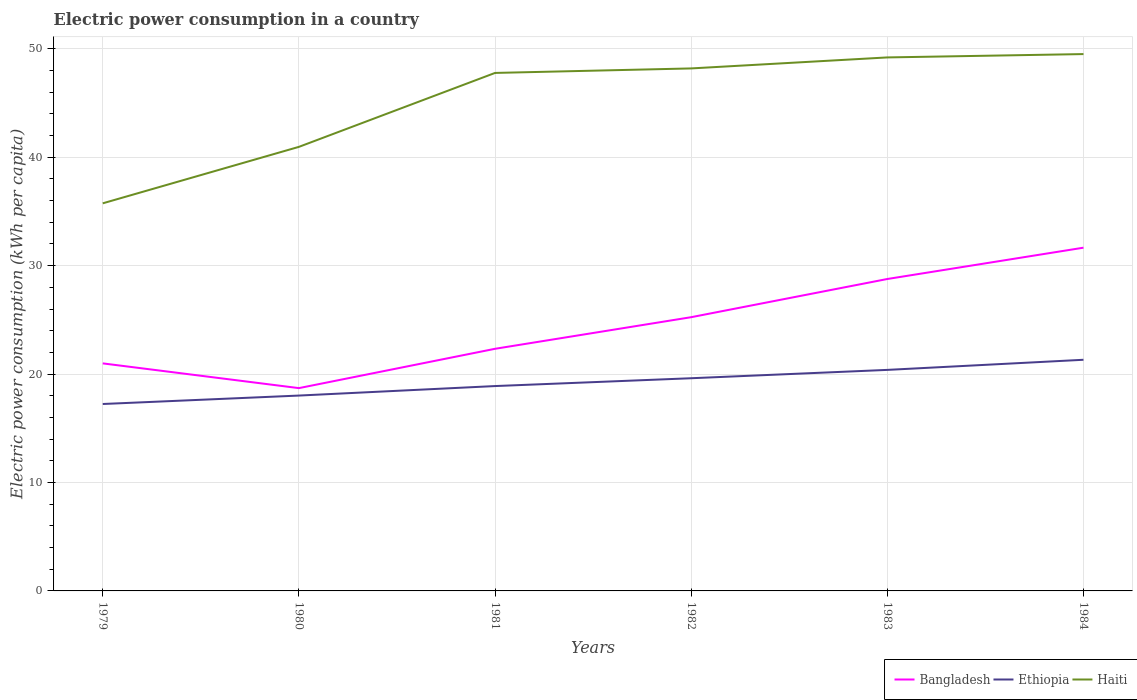How many different coloured lines are there?
Offer a terse response. 3. Across all years, what is the maximum electric power consumption in in Bangladesh?
Your response must be concise. 18.71. In which year was the electric power consumption in in Ethiopia maximum?
Your answer should be very brief. 1979. What is the total electric power consumption in in Bangladesh in the graph?
Give a very brief answer. -3.52. What is the difference between the highest and the second highest electric power consumption in in Haiti?
Your response must be concise. 13.77. What is the difference between the highest and the lowest electric power consumption in in Bangladesh?
Your answer should be compact. 3. Is the electric power consumption in in Haiti strictly greater than the electric power consumption in in Bangladesh over the years?
Your answer should be compact. No. How many lines are there?
Offer a terse response. 3. Are the values on the major ticks of Y-axis written in scientific E-notation?
Keep it short and to the point. No. Does the graph contain any zero values?
Your answer should be compact. No. How many legend labels are there?
Offer a terse response. 3. How are the legend labels stacked?
Keep it short and to the point. Horizontal. What is the title of the graph?
Provide a short and direct response. Electric power consumption in a country. Does "Cambodia" appear as one of the legend labels in the graph?
Make the answer very short. No. What is the label or title of the X-axis?
Keep it short and to the point. Years. What is the label or title of the Y-axis?
Offer a very short reply. Electric power consumption (kWh per capita). What is the Electric power consumption (kWh per capita) in Bangladesh in 1979?
Provide a succinct answer. 20.99. What is the Electric power consumption (kWh per capita) in Ethiopia in 1979?
Keep it short and to the point. 17.24. What is the Electric power consumption (kWh per capita) of Haiti in 1979?
Keep it short and to the point. 35.75. What is the Electric power consumption (kWh per capita) in Bangladesh in 1980?
Offer a terse response. 18.71. What is the Electric power consumption (kWh per capita) in Ethiopia in 1980?
Offer a terse response. 18.02. What is the Electric power consumption (kWh per capita) in Haiti in 1980?
Give a very brief answer. 40.96. What is the Electric power consumption (kWh per capita) in Bangladesh in 1981?
Your answer should be compact. 22.33. What is the Electric power consumption (kWh per capita) of Ethiopia in 1981?
Your response must be concise. 18.9. What is the Electric power consumption (kWh per capita) of Haiti in 1981?
Provide a succinct answer. 47.78. What is the Electric power consumption (kWh per capita) of Bangladesh in 1982?
Provide a succinct answer. 25.25. What is the Electric power consumption (kWh per capita) in Ethiopia in 1982?
Your answer should be very brief. 19.62. What is the Electric power consumption (kWh per capita) of Haiti in 1982?
Provide a short and direct response. 48.19. What is the Electric power consumption (kWh per capita) in Bangladesh in 1983?
Your answer should be very brief. 28.77. What is the Electric power consumption (kWh per capita) in Ethiopia in 1983?
Ensure brevity in your answer.  20.39. What is the Electric power consumption (kWh per capita) in Haiti in 1983?
Provide a succinct answer. 49.21. What is the Electric power consumption (kWh per capita) in Bangladesh in 1984?
Your answer should be compact. 31.66. What is the Electric power consumption (kWh per capita) in Ethiopia in 1984?
Offer a terse response. 21.32. What is the Electric power consumption (kWh per capita) of Haiti in 1984?
Make the answer very short. 49.52. Across all years, what is the maximum Electric power consumption (kWh per capita) of Bangladesh?
Ensure brevity in your answer.  31.66. Across all years, what is the maximum Electric power consumption (kWh per capita) in Ethiopia?
Offer a terse response. 21.32. Across all years, what is the maximum Electric power consumption (kWh per capita) in Haiti?
Keep it short and to the point. 49.52. Across all years, what is the minimum Electric power consumption (kWh per capita) of Bangladesh?
Provide a succinct answer. 18.71. Across all years, what is the minimum Electric power consumption (kWh per capita) of Ethiopia?
Ensure brevity in your answer.  17.24. Across all years, what is the minimum Electric power consumption (kWh per capita) of Haiti?
Give a very brief answer. 35.75. What is the total Electric power consumption (kWh per capita) in Bangladesh in the graph?
Offer a very short reply. 147.7. What is the total Electric power consumption (kWh per capita) in Ethiopia in the graph?
Provide a succinct answer. 115.48. What is the total Electric power consumption (kWh per capita) of Haiti in the graph?
Offer a terse response. 271.4. What is the difference between the Electric power consumption (kWh per capita) of Bangladesh in 1979 and that in 1980?
Offer a terse response. 2.28. What is the difference between the Electric power consumption (kWh per capita) of Ethiopia in 1979 and that in 1980?
Provide a succinct answer. -0.78. What is the difference between the Electric power consumption (kWh per capita) of Haiti in 1979 and that in 1980?
Give a very brief answer. -5.21. What is the difference between the Electric power consumption (kWh per capita) in Bangladesh in 1979 and that in 1981?
Provide a succinct answer. -1.34. What is the difference between the Electric power consumption (kWh per capita) in Ethiopia in 1979 and that in 1981?
Your answer should be very brief. -1.65. What is the difference between the Electric power consumption (kWh per capita) of Haiti in 1979 and that in 1981?
Your answer should be compact. -12.03. What is the difference between the Electric power consumption (kWh per capita) in Bangladesh in 1979 and that in 1982?
Offer a very short reply. -4.26. What is the difference between the Electric power consumption (kWh per capita) of Ethiopia in 1979 and that in 1982?
Provide a succinct answer. -2.38. What is the difference between the Electric power consumption (kWh per capita) of Haiti in 1979 and that in 1982?
Your response must be concise. -12.44. What is the difference between the Electric power consumption (kWh per capita) of Bangladesh in 1979 and that in 1983?
Provide a short and direct response. -7.78. What is the difference between the Electric power consumption (kWh per capita) in Ethiopia in 1979 and that in 1983?
Offer a terse response. -3.15. What is the difference between the Electric power consumption (kWh per capita) in Haiti in 1979 and that in 1983?
Your response must be concise. -13.46. What is the difference between the Electric power consumption (kWh per capita) of Bangladesh in 1979 and that in 1984?
Give a very brief answer. -10.67. What is the difference between the Electric power consumption (kWh per capita) of Ethiopia in 1979 and that in 1984?
Offer a very short reply. -4.08. What is the difference between the Electric power consumption (kWh per capita) in Haiti in 1979 and that in 1984?
Provide a short and direct response. -13.77. What is the difference between the Electric power consumption (kWh per capita) of Bangladesh in 1980 and that in 1981?
Make the answer very short. -3.63. What is the difference between the Electric power consumption (kWh per capita) in Ethiopia in 1980 and that in 1981?
Your answer should be compact. -0.88. What is the difference between the Electric power consumption (kWh per capita) of Haiti in 1980 and that in 1981?
Provide a short and direct response. -6.82. What is the difference between the Electric power consumption (kWh per capita) of Bangladesh in 1980 and that in 1982?
Make the answer very short. -6.54. What is the difference between the Electric power consumption (kWh per capita) in Ethiopia in 1980 and that in 1982?
Provide a succinct answer. -1.6. What is the difference between the Electric power consumption (kWh per capita) in Haiti in 1980 and that in 1982?
Your answer should be compact. -7.24. What is the difference between the Electric power consumption (kWh per capita) of Bangladesh in 1980 and that in 1983?
Offer a very short reply. -10.06. What is the difference between the Electric power consumption (kWh per capita) of Ethiopia in 1980 and that in 1983?
Your response must be concise. -2.37. What is the difference between the Electric power consumption (kWh per capita) in Haiti in 1980 and that in 1983?
Your response must be concise. -8.25. What is the difference between the Electric power consumption (kWh per capita) in Bangladesh in 1980 and that in 1984?
Make the answer very short. -12.95. What is the difference between the Electric power consumption (kWh per capita) in Ethiopia in 1980 and that in 1984?
Offer a terse response. -3.3. What is the difference between the Electric power consumption (kWh per capita) in Haiti in 1980 and that in 1984?
Provide a succinct answer. -8.56. What is the difference between the Electric power consumption (kWh per capita) in Bangladesh in 1981 and that in 1982?
Ensure brevity in your answer.  -2.92. What is the difference between the Electric power consumption (kWh per capita) of Ethiopia in 1981 and that in 1982?
Give a very brief answer. -0.72. What is the difference between the Electric power consumption (kWh per capita) of Haiti in 1981 and that in 1982?
Keep it short and to the point. -0.42. What is the difference between the Electric power consumption (kWh per capita) in Bangladesh in 1981 and that in 1983?
Ensure brevity in your answer.  -6.44. What is the difference between the Electric power consumption (kWh per capita) in Ethiopia in 1981 and that in 1983?
Keep it short and to the point. -1.49. What is the difference between the Electric power consumption (kWh per capita) in Haiti in 1981 and that in 1983?
Your response must be concise. -1.43. What is the difference between the Electric power consumption (kWh per capita) of Bangladesh in 1981 and that in 1984?
Your response must be concise. -9.33. What is the difference between the Electric power consumption (kWh per capita) of Ethiopia in 1981 and that in 1984?
Give a very brief answer. -2.42. What is the difference between the Electric power consumption (kWh per capita) of Haiti in 1981 and that in 1984?
Your response must be concise. -1.74. What is the difference between the Electric power consumption (kWh per capita) of Bangladesh in 1982 and that in 1983?
Your response must be concise. -3.52. What is the difference between the Electric power consumption (kWh per capita) in Ethiopia in 1982 and that in 1983?
Offer a very short reply. -0.77. What is the difference between the Electric power consumption (kWh per capita) of Haiti in 1982 and that in 1983?
Provide a short and direct response. -1.01. What is the difference between the Electric power consumption (kWh per capita) of Bangladesh in 1982 and that in 1984?
Make the answer very short. -6.41. What is the difference between the Electric power consumption (kWh per capita) of Ethiopia in 1982 and that in 1984?
Keep it short and to the point. -1.7. What is the difference between the Electric power consumption (kWh per capita) of Haiti in 1982 and that in 1984?
Offer a terse response. -1.32. What is the difference between the Electric power consumption (kWh per capita) in Bangladesh in 1983 and that in 1984?
Your response must be concise. -2.89. What is the difference between the Electric power consumption (kWh per capita) in Ethiopia in 1983 and that in 1984?
Provide a succinct answer. -0.93. What is the difference between the Electric power consumption (kWh per capita) of Haiti in 1983 and that in 1984?
Give a very brief answer. -0.31. What is the difference between the Electric power consumption (kWh per capita) of Bangladesh in 1979 and the Electric power consumption (kWh per capita) of Ethiopia in 1980?
Offer a terse response. 2.97. What is the difference between the Electric power consumption (kWh per capita) of Bangladesh in 1979 and the Electric power consumption (kWh per capita) of Haiti in 1980?
Give a very brief answer. -19.97. What is the difference between the Electric power consumption (kWh per capita) in Ethiopia in 1979 and the Electric power consumption (kWh per capita) in Haiti in 1980?
Offer a very short reply. -23.72. What is the difference between the Electric power consumption (kWh per capita) of Bangladesh in 1979 and the Electric power consumption (kWh per capita) of Ethiopia in 1981?
Give a very brief answer. 2.09. What is the difference between the Electric power consumption (kWh per capita) of Bangladesh in 1979 and the Electric power consumption (kWh per capita) of Haiti in 1981?
Ensure brevity in your answer.  -26.79. What is the difference between the Electric power consumption (kWh per capita) in Ethiopia in 1979 and the Electric power consumption (kWh per capita) in Haiti in 1981?
Your response must be concise. -30.54. What is the difference between the Electric power consumption (kWh per capita) of Bangladesh in 1979 and the Electric power consumption (kWh per capita) of Ethiopia in 1982?
Keep it short and to the point. 1.37. What is the difference between the Electric power consumption (kWh per capita) in Bangladesh in 1979 and the Electric power consumption (kWh per capita) in Haiti in 1982?
Your answer should be compact. -27.2. What is the difference between the Electric power consumption (kWh per capita) of Ethiopia in 1979 and the Electric power consumption (kWh per capita) of Haiti in 1982?
Make the answer very short. -30.95. What is the difference between the Electric power consumption (kWh per capita) in Bangladesh in 1979 and the Electric power consumption (kWh per capita) in Ethiopia in 1983?
Make the answer very short. 0.6. What is the difference between the Electric power consumption (kWh per capita) of Bangladesh in 1979 and the Electric power consumption (kWh per capita) of Haiti in 1983?
Make the answer very short. -28.22. What is the difference between the Electric power consumption (kWh per capita) in Ethiopia in 1979 and the Electric power consumption (kWh per capita) in Haiti in 1983?
Give a very brief answer. -31.97. What is the difference between the Electric power consumption (kWh per capita) in Bangladesh in 1979 and the Electric power consumption (kWh per capita) in Ethiopia in 1984?
Make the answer very short. -0.33. What is the difference between the Electric power consumption (kWh per capita) in Bangladesh in 1979 and the Electric power consumption (kWh per capita) in Haiti in 1984?
Offer a terse response. -28.53. What is the difference between the Electric power consumption (kWh per capita) in Ethiopia in 1979 and the Electric power consumption (kWh per capita) in Haiti in 1984?
Offer a very short reply. -32.28. What is the difference between the Electric power consumption (kWh per capita) of Bangladesh in 1980 and the Electric power consumption (kWh per capita) of Ethiopia in 1981?
Give a very brief answer. -0.19. What is the difference between the Electric power consumption (kWh per capita) of Bangladesh in 1980 and the Electric power consumption (kWh per capita) of Haiti in 1981?
Give a very brief answer. -29.07. What is the difference between the Electric power consumption (kWh per capita) in Ethiopia in 1980 and the Electric power consumption (kWh per capita) in Haiti in 1981?
Keep it short and to the point. -29.76. What is the difference between the Electric power consumption (kWh per capita) of Bangladesh in 1980 and the Electric power consumption (kWh per capita) of Ethiopia in 1982?
Ensure brevity in your answer.  -0.91. What is the difference between the Electric power consumption (kWh per capita) in Bangladesh in 1980 and the Electric power consumption (kWh per capita) in Haiti in 1982?
Your answer should be very brief. -29.49. What is the difference between the Electric power consumption (kWh per capita) of Ethiopia in 1980 and the Electric power consumption (kWh per capita) of Haiti in 1982?
Give a very brief answer. -30.17. What is the difference between the Electric power consumption (kWh per capita) in Bangladesh in 1980 and the Electric power consumption (kWh per capita) in Ethiopia in 1983?
Offer a very short reply. -1.68. What is the difference between the Electric power consumption (kWh per capita) in Bangladesh in 1980 and the Electric power consumption (kWh per capita) in Haiti in 1983?
Ensure brevity in your answer.  -30.5. What is the difference between the Electric power consumption (kWh per capita) of Ethiopia in 1980 and the Electric power consumption (kWh per capita) of Haiti in 1983?
Offer a very short reply. -31.19. What is the difference between the Electric power consumption (kWh per capita) in Bangladesh in 1980 and the Electric power consumption (kWh per capita) in Ethiopia in 1984?
Ensure brevity in your answer.  -2.61. What is the difference between the Electric power consumption (kWh per capita) of Bangladesh in 1980 and the Electric power consumption (kWh per capita) of Haiti in 1984?
Provide a short and direct response. -30.81. What is the difference between the Electric power consumption (kWh per capita) in Ethiopia in 1980 and the Electric power consumption (kWh per capita) in Haiti in 1984?
Offer a terse response. -31.5. What is the difference between the Electric power consumption (kWh per capita) of Bangladesh in 1981 and the Electric power consumption (kWh per capita) of Ethiopia in 1982?
Provide a short and direct response. 2.71. What is the difference between the Electric power consumption (kWh per capita) in Bangladesh in 1981 and the Electric power consumption (kWh per capita) in Haiti in 1982?
Keep it short and to the point. -25.86. What is the difference between the Electric power consumption (kWh per capita) in Ethiopia in 1981 and the Electric power consumption (kWh per capita) in Haiti in 1982?
Keep it short and to the point. -29.3. What is the difference between the Electric power consumption (kWh per capita) in Bangladesh in 1981 and the Electric power consumption (kWh per capita) in Ethiopia in 1983?
Offer a terse response. 1.95. What is the difference between the Electric power consumption (kWh per capita) in Bangladesh in 1981 and the Electric power consumption (kWh per capita) in Haiti in 1983?
Your answer should be compact. -26.87. What is the difference between the Electric power consumption (kWh per capita) of Ethiopia in 1981 and the Electric power consumption (kWh per capita) of Haiti in 1983?
Give a very brief answer. -30.31. What is the difference between the Electric power consumption (kWh per capita) in Bangladesh in 1981 and the Electric power consumption (kWh per capita) in Ethiopia in 1984?
Your response must be concise. 1.01. What is the difference between the Electric power consumption (kWh per capita) of Bangladesh in 1981 and the Electric power consumption (kWh per capita) of Haiti in 1984?
Your response must be concise. -27.18. What is the difference between the Electric power consumption (kWh per capita) of Ethiopia in 1981 and the Electric power consumption (kWh per capita) of Haiti in 1984?
Offer a terse response. -30.62. What is the difference between the Electric power consumption (kWh per capita) of Bangladesh in 1982 and the Electric power consumption (kWh per capita) of Ethiopia in 1983?
Your answer should be compact. 4.86. What is the difference between the Electric power consumption (kWh per capita) of Bangladesh in 1982 and the Electric power consumption (kWh per capita) of Haiti in 1983?
Make the answer very short. -23.96. What is the difference between the Electric power consumption (kWh per capita) in Ethiopia in 1982 and the Electric power consumption (kWh per capita) in Haiti in 1983?
Your response must be concise. -29.59. What is the difference between the Electric power consumption (kWh per capita) of Bangladesh in 1982 and the Electric power consumption (kWh per capita) of Ethiopia in 1984?
Offer a very short reply. 3.93. What is the difference between the Electric power consumption (kWh per capita) in Bangladesh in 1982 and the Electric power consumption (kWh per capita) in Haiti in 1984?
Your answer should be compact. -24.27. What is the difference between the Electric power consumption (kWh per capita) in Ethiopia in 1982 and the Electric power consumption (kWh per capita) in Haiti in 1984?
Ensure brevity in your answer.  -29.9. What is the difference between the Electric power consumption (kWh per capita) of Bangladesh in 1983 and the Electric power consumption (kWh per capita) of Ethiopia in 1984?
Offer a very short reply. 7.45. What is the difference between the Electric power consumption (kWh per capita) of Bangladesh in 1983 and the Electric power consumption (kWh per capita) of Haiti in 1984?
Make the answer very short. -20.75. What is the difference between the Electric power consumption (kWh per capita) of Ethiopia in 1983 and the Electric power consumption (kWh per capita) of Haiti in 1984?
Keep it short and to the point. -29.13. What is the average Electric power consumption (kWh per capita) of Bangladesh per year?
Give a very brief answer. 24.62. What is the average Electric power consumption (kWh per capita) of Ethiopia per year?
Your answer should be compact. 19.25. What is the average Electric power consumption (kWh per capita) in Haiti per year?
Provide a succinct answer. 45.23. In the year 1979, what is the difference between the Electric power consumption (kWh per capita) in Bangladesh and Electric power consumption (kWh per capita) in Ethiopia?
Your answer should be very brief. 3.75. In the year 1979, what is the difference between the Electric power consumption (kWh per capita) in Bangladesh and Electric power consumption (kWh per capita) in Haiti?
Keep it short and to the point. -14.76. In the year 1979, what is the difference between the Electric power consumption (kWh per capita) in Ethiopia and Electric power consumption (kWh per capita) in Haiti?
Keep it short and to the point. -18.51. In the year 1980, what is the difference between the Electric power consumption (kWh per capita) of Bangladesh and Electric power consumption (kWh per capita) of Ethiopia?
Provide a short and direct response. 0.69. In the year 1980, what is the difference between the Electric power consumption (kWh per capita) in Bangladesh and Electric power consumption (kWh per capita) in Haiti?
Make the answer very short. -22.25. In the year 1980, what is the difference between the Electric power consumption (kWh per capita) of Ethiopia and Electric power consumption (kWh per capita) of Haiti?
Give a very brief answer. -22.94. In the year 1981, what is the difference between the Electric power consumption (kWh per capita) in Bangladesh and Electric power consumption (kWh per capita) in Ethiopia?
Your response must be concise. 3.44. In the year 1981, what is the difference between the Electric power consumption (kWh per capita) of Bangladesh and Electric power consumption (kWh per capita) of Haiti?
Provide a short and direct response. -25.44. In the year 1981, what is the difference between the Electric power consumption (kWh per capita) in Ethiopia and Electric power consumption (kWh per capita) in Haiti?
Offer a terse response. -28.88. In the year 1982, what is the difference between the Electric power consumption (kWh per capita) of Bangladesh and Electric power consumption (kWh per capita) of Ethiopia?
Provide a short and direct response. 5.63. In the year 1982, what is the difference between the Electric power consumption (kWh per capita) of Bangladesh and Electric power consumption (kWh per capita) of Haiti?
Your response must be concise. -22.94. In the year 1982, what is the difference between the Electric power consumption (kWh per capita) in Ethiopia and Electric power consumption (kWh per capita) in Haiti?
Your answer should be compact. -28.57. In the year 1983, what is the difference between the Electric power consumption (kWh per capita) of Bangladesh and Electric power consumption (kWh per capita) of Ethiopia?
Ensure brevity in your answer.  8.38. In the year 1983, what is the difference between the Electric power consumption (kWh per capita) of Bangladesh and Electric power consumption (kWh per capita) of Haiti?
Your answer should be very brief. -20.44. In the year 1983, what is the difference between the Electric power consumption (kWh per capita) in Ethiopia and Electric power consumption (kWh per capita) in Haiti?
Make the answer very short. -28.82. In the year 1984, what is the difference between the Electric power consumption (kWh per capita) in Bangladesh and Electric power consumption (kWh per capita) in Ethiopia?
Provide a short and direct response. 10.34. In the year 1984, what is the difference between the Electric power consumption (kWh per capita) in Bangladesh and Electric power consumption (kWh per capita) in Haiti?
Give a very brief answer. -17.86. In the year 1984, what is the difference between the Electric power consumption (kWh per capita) of Ethiopia and Electric power consumption (kWh per capita) of Haiti?
Your response must be concise. -28.2. What is the ratio of the Electric power consumption (kWh per capita) of Bangladesh in 1979 to that in 1980?
Make the answer very short. 1.12. What is the ratio of the Electric power consumption (kWh per capita) of Ethiopia in 1979 to that in 1980?
Keep it short and to the point. 0.96. What is the ratio of the Electric power consumption (kWh per capita) in Haiti in 1979 to that in 1980?
Your answer should be very brief. 0.87. What is the ratio of the Electric power consumption (kWh per capita) of Bangladesh in 1979 to that in 1981?
Your response must be concise. 0.94. What is the ratio of the Electric power consumption (kWh per capita) of Ethiopia in 1979 to that in 1981?
Your answer should be compact. 0.91. What is the ratio of the Electric power consumption (kWh per capita) of Haiti in 1979 to that in 1981?
Provide a short and direct response. 0.75. What is the ratio of the Electric power consumption (kWh per capita) of Bangladesh in 1979 to that in 1982?
Offer a very short reply. 0.83. What is the ratio of the Electric power consumption (kWh per capita) in Ethiopia in 1979 to that in 1982?
Your answer should be very brief. 0.88. What is the ratio of the Electric power consumption (kWh per capita) of Haiti in 1979 to that in 1982?
Keep it short and to the point. 0.74. What is the ratio of the Electric power consumption (kWh per capita) of Bangladesh in 1979 to that in 1983?
Offer a very short reply. 0.73. What is the ratio of the Electric power consumption (kWh per capita) of Ethiopia in 1979 to that in 1983?
Offer a terse response. 0.85. What is the ratio of the Electric power consumption (kWh per capita) in Haiti in 1979 to that in 1983?
Ensure brevity in your answer.  0.73. What is the ratio of the Electric power consumption (kWh per capita) of Bangladesh in 1979 to that in 1984?
Provide a short and direct response. 0.66. What is the ratio of the Electric power consumption (kWh per capita) in Ethiopia in 1979 to that in 1984?
Provide a short and direct response. 0.81. What is the ratio of the Electric power consumption (kWh per capita) in Haiti in 1979 to that in 1984?
Make the answer very short. 0.72. What is the ratio of the Electric power consumption (kWh per capita) of Bangladesh in 1980 to that in 1981?
Provide a short and direct response. 0.84. What is the ratio of the Electric power consumption (kWh per capita) of Ethiopia in 1980 to that in 1981?
Offer a terse response. 0.95. What is the ratio of the Electric power consumption (kWh per capita) in Haiti in 1980 to that in 1981?
Your response must be concise. 0.86. What is the ratio of the Electric power consumption (kWh per capita) of Bangladesh in 1980 to that in 1982?
Your response must be concise. 0.74. What is the ratio of the Electric power consumption (kWh per capita) of Ethiopia in 1980 to that in 1982?
Your answer should be compact. 0.92. What is the ratio of the Electric power consumption (kWh per capita) of Haiti in 1980 to that in 1982?
Keep it short and to the point. 0.85. What is the ratio of the Electric power consumption (kWh per capita) in Bangladesh in 1980 to that in 1983?
Your response must be concise. 0.65. What is the ratio of the Electric power consumption (kWh per capita) of Ethiopia in 1980 to that in 1983?
Offer a very short reply. 0.88. What is the ratio of the Electric power consumption (kWh per capita) of Haiti in 1980 to that in 1983?
Make the answer very short. 0.83. What is the ratio of the Electric power consumption (kWh per capita) in Bangladesh in 1980 to that in 1984?
Give a very brief answer. 0.59. What is the ratio of the Electric power consumption (kWh per capita) of Ethiopia in 1980 to that in 1984?
Your answer should be compact. 0.85. What is the ratio of the Electric power consumption (kWh per capita) of Haiti in 1980 to that in 1984?
Offer a very short reply. 0.83. What is the ratio of the Electric power consumption (kWh per capita) of Bangladesh in 1981 to that in 1982?
Your answer should be compact. 0.88. What is the ratio of the Electric power consumption (kWh per capita) of Ethiopia in 1981 to that in 1982?
Provide a succinct answer. 0.96. What is the ratio of the Electric power consumption (kWh per capita) in Haiti in 1981 to that in 1982?
Your answer should be compact. 0.99. What is the ratio of the Electric power consumption (kWh per capita) in Bangladesh in 1981 to that in 1983?
Offer a terse response. 0.78. What is the ratio of the Electric power consumption (kWh per capita) in Ethiopia in 1981 to that in 1983?
Keep it short and to the point. 0.93. What is the ratio of the Electric power consumption (kWh per capita) of Haiti in 1981 to that in 1983?
Offer a very short reply. 0.97. What is the ratio of the Electric power consumption (kWh per capita) of Bangladesh in 1981 to that in 1984?
Your answer should be very brief. 0.71. What is the ratio of the Electric power consumption (kWh per capita) in Ethiopia in 1981 to that in 1984?
Make the answer very short. 0.89. What is the ratio of the Electric power consumption (kWh per capita) of Haiti in 1981 to that in 1984?
Ensure brevity in your answer.  0.96. What is the ratio of the Electric power consumption (kWh per capita) of Bangladesh in 1982 to that in 1983?
Provide a succinct answer. 0.88. What is the ratio of the Electric power consumption (kWh per capita) in Ethiopia in 1982 to that in 1983?
Provide a succinct answer. 0.96. What is the ratio of the Electric power consumption (kWh per capita) in Haiti in 1982 to that in 1983?
Offer a very short reply. 0.98. What is the ratio of the Electric power consumption (kWh per capita) of Bangladesh in 1982 to that in 1984?
Offer a terse response. 0.8. What is the ratio of the Electric power consumption (kWh per capita) of Ethiopia in 1982 to that in 1984?
Offer a terse response. 0.92. What is the ratio of the Electric power consumption (kWh per capita) in Haiti in 1982 to that in 1984?
Give a very brief answer. 0.97. What is the ratio of the Electric power consumption (kWh per capita) in Bangladesh in 1983 to that in 1984?
Your response must be concise. 0.91. What is the ratio of the Electric power consumption (kWh per capita) in Ethiopia in 1983 to that in 1984?
Your answer should be very brief. 0.96. What is the difference between the highest and the second highest Electric power consumption (kWh per capita) of Bangladesh?
Your response must be concise. 2.89. What is the difference between the highest and the second highest Electric power consumption (kWh per capita) of Ethiopia?
Offer a terse response. 0.93. What is the difference between the highest and the second highest Electric power consumption (kWh per capita) of Haiti?
Keep it short and to the point. 0.31. What is the difference between the highest and the lowest Electric power consumption (kWh per capita) of Bangladesh?
Your answer should be compact. 12.95. What is the difference between the highest and the lowest Electric power consumption (kWh per capita) in Ethiopia?
Provide a short and direct response. 4.08. What is the difference between the highest and the lowest Electric power consumption (kWh per capita) in Haiti?
Give a very brief answer. 13.77. 